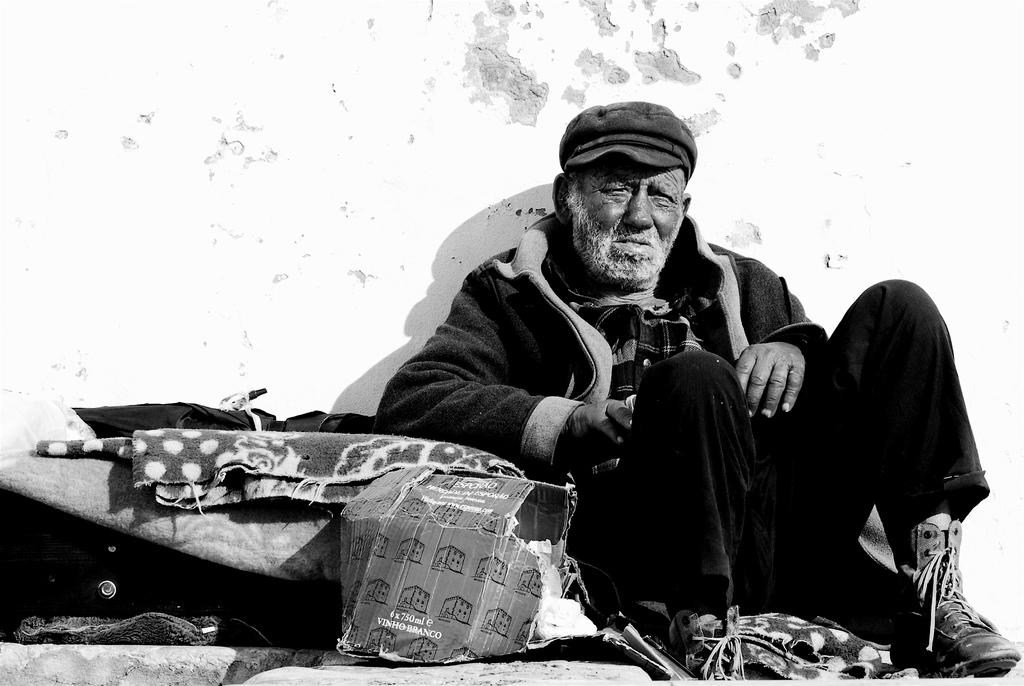What is the main subject in the center of the image? There is a man sitting in the center of the image. What type of objects can be seen in the image? There are boxes and blankets in the image. Are there any other objects present in the image? Yes, there are other objects in the image. What can be seen in the background of the image? There is a wall in the background of the image. How many times does the road appear in the image? There is no road present in the image. What is the amount of water in the image? There is no water present in the image. 